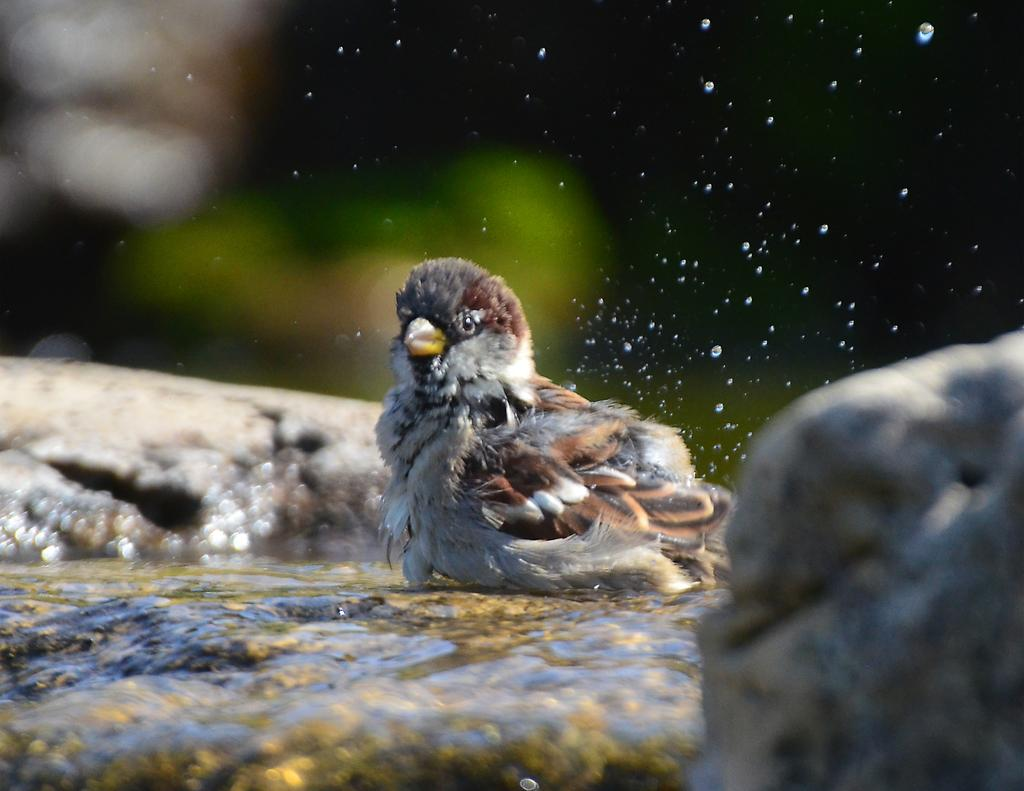What type of bird can be seen in the image? There is a brown and white color bird in the image. Can you describe the quality of the background in the image? The image is blurry in the background. How many children are playing with the horn in the image? There are no children or horns present in the image; it features a bird and a blurry background. 